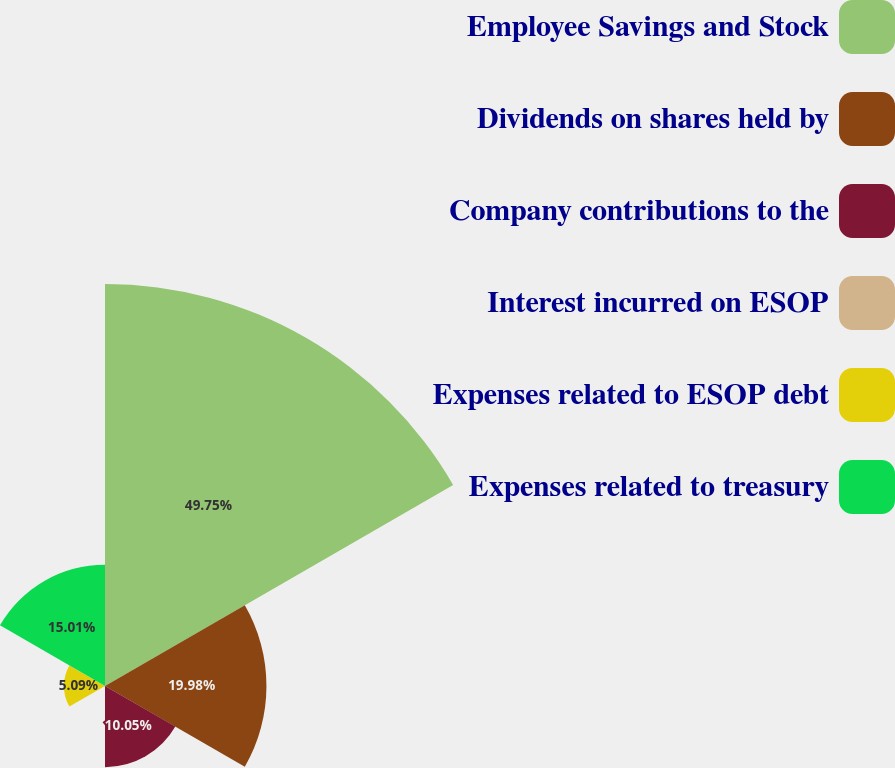Convert chart. <chart><loc_0><loc_0><loc_500><loc_500><pie_chart><fcel>Employee Savings and Stock<fcel>Dividends on shares held by<fcel>Company contributions to the<fcel>Interest incurred on ESOP<fcel>Expenses related to ESOP debt<fcel>Expenses related to treasury<nl><fcel>49.75%<fcel>19.98%<fcel>10.05%<fcel>0.12%<fcel>5.09%<fcel>15.01%<nl></chart> 